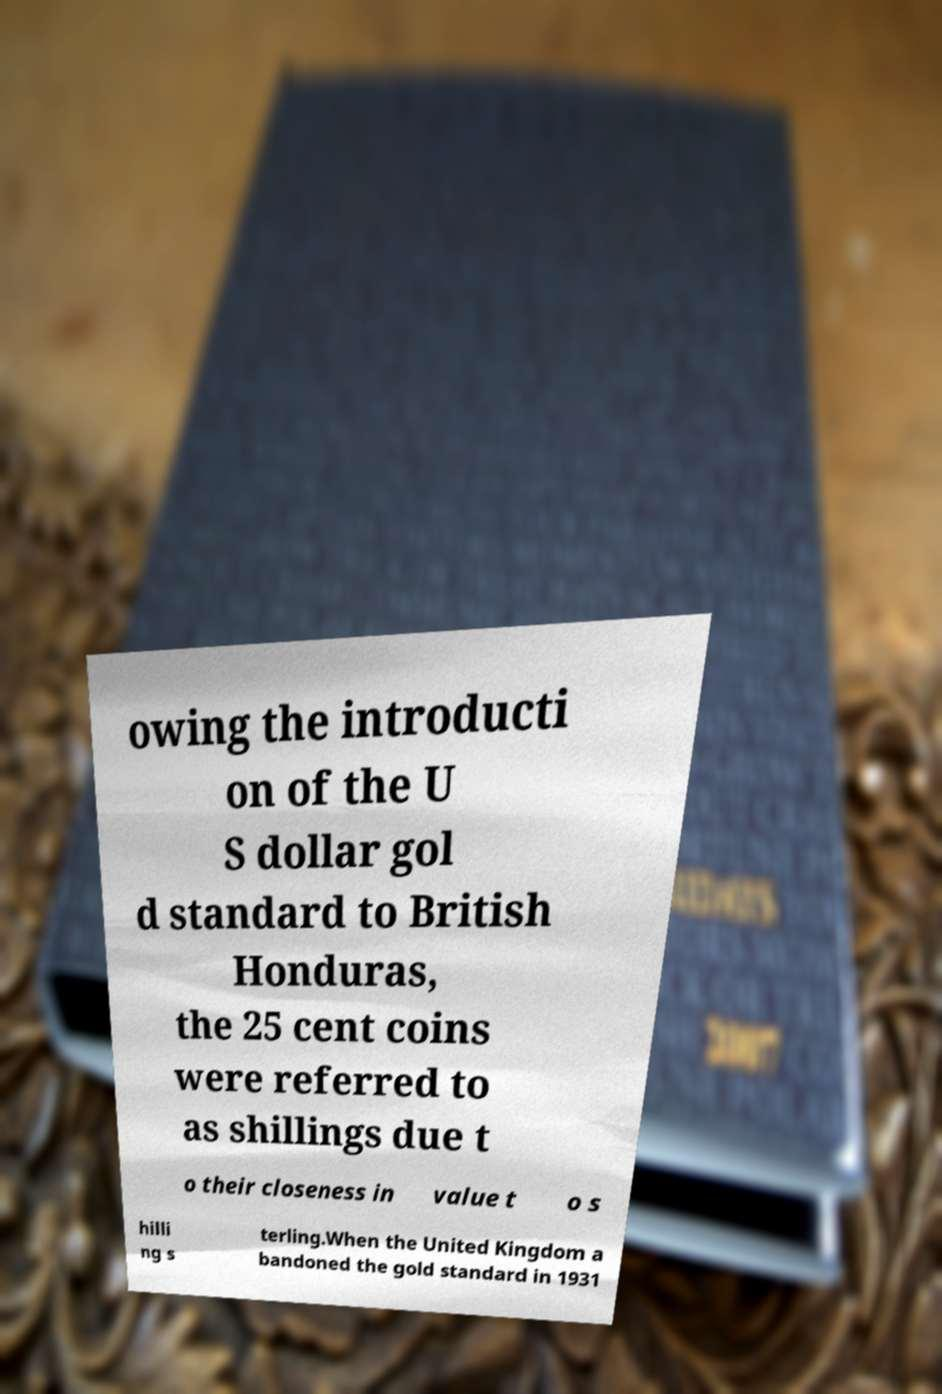Please read and relay the text visible in this image. What does it say? owing the introducti on of the U S dollar gol d standard to British Honduras, the 25 cent coins were referred to as shillings due t o their closeness in value t o s hilli ng s terling.When the United Kingdom a bandoned the gold standard in 1931 